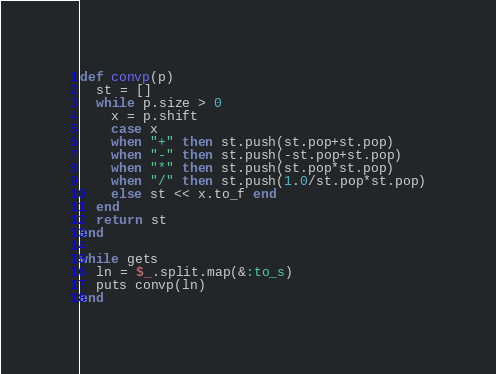<code> <loc_0><loc_0><loc_500><loc_500><_Ruby_>def convp(p)
  st = []
  while p.size > 0
    x = p.shift
    case x
    when "+" then st.push(st.pop+st.pop)
    when "-" then st.push(-st.pop+st.pop)
    when "*" then st.push(st.pop*st.pop)
    when "/" then st.push(1.0/st.pop*st.pop)
    else st << x.to_f end
  end
  return st
end

while gets
  ln = $_.split.map(&:to_s)
  puts convp(ln)
end</code> 